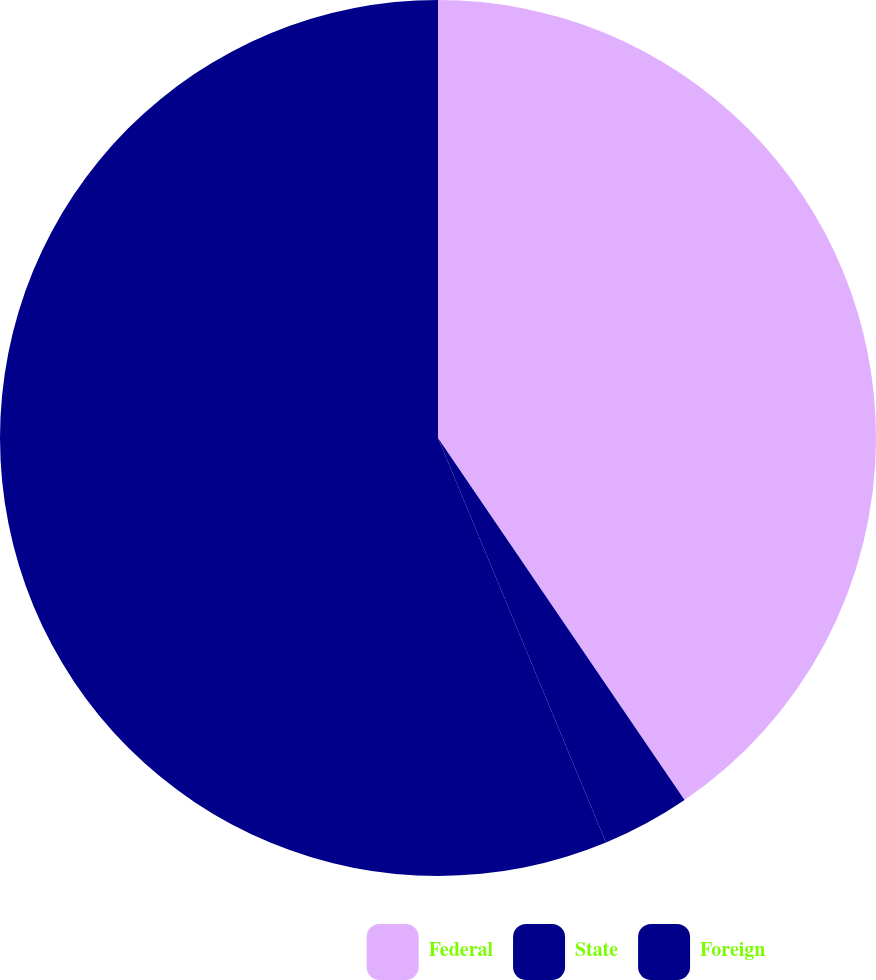Convert chart to OTSL. <chart><loc_0><loc_0><loc_500><loc_500><pie_chart><fcel>Federal<fcel>State<fcel>Foreign<nl><fcel>40.48%<fcel>3.25%<fcel>56.26%<nl></chart> 